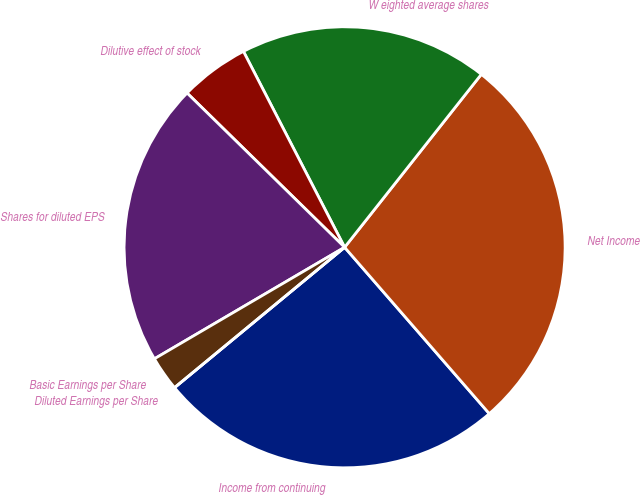Convert chart. <chart><loc_0><loc_0><loc_500><loc_500><pie_chart><fcel>Income from continuing<fcel>Net Income<fcel>W eighted average shares<fcel>Dilutive effect of stock<fcel>Shares for diluted EPS<fcel>Basic Earnings per Share<fcel>Diluted Earnings per Share<nl><fcel>25.41%<fcel>27.96%<fcel>18.23%<fcel>5.08%<fcel>20.77%<fcel>2.54%<fcel>0.0%<nl></chart> 